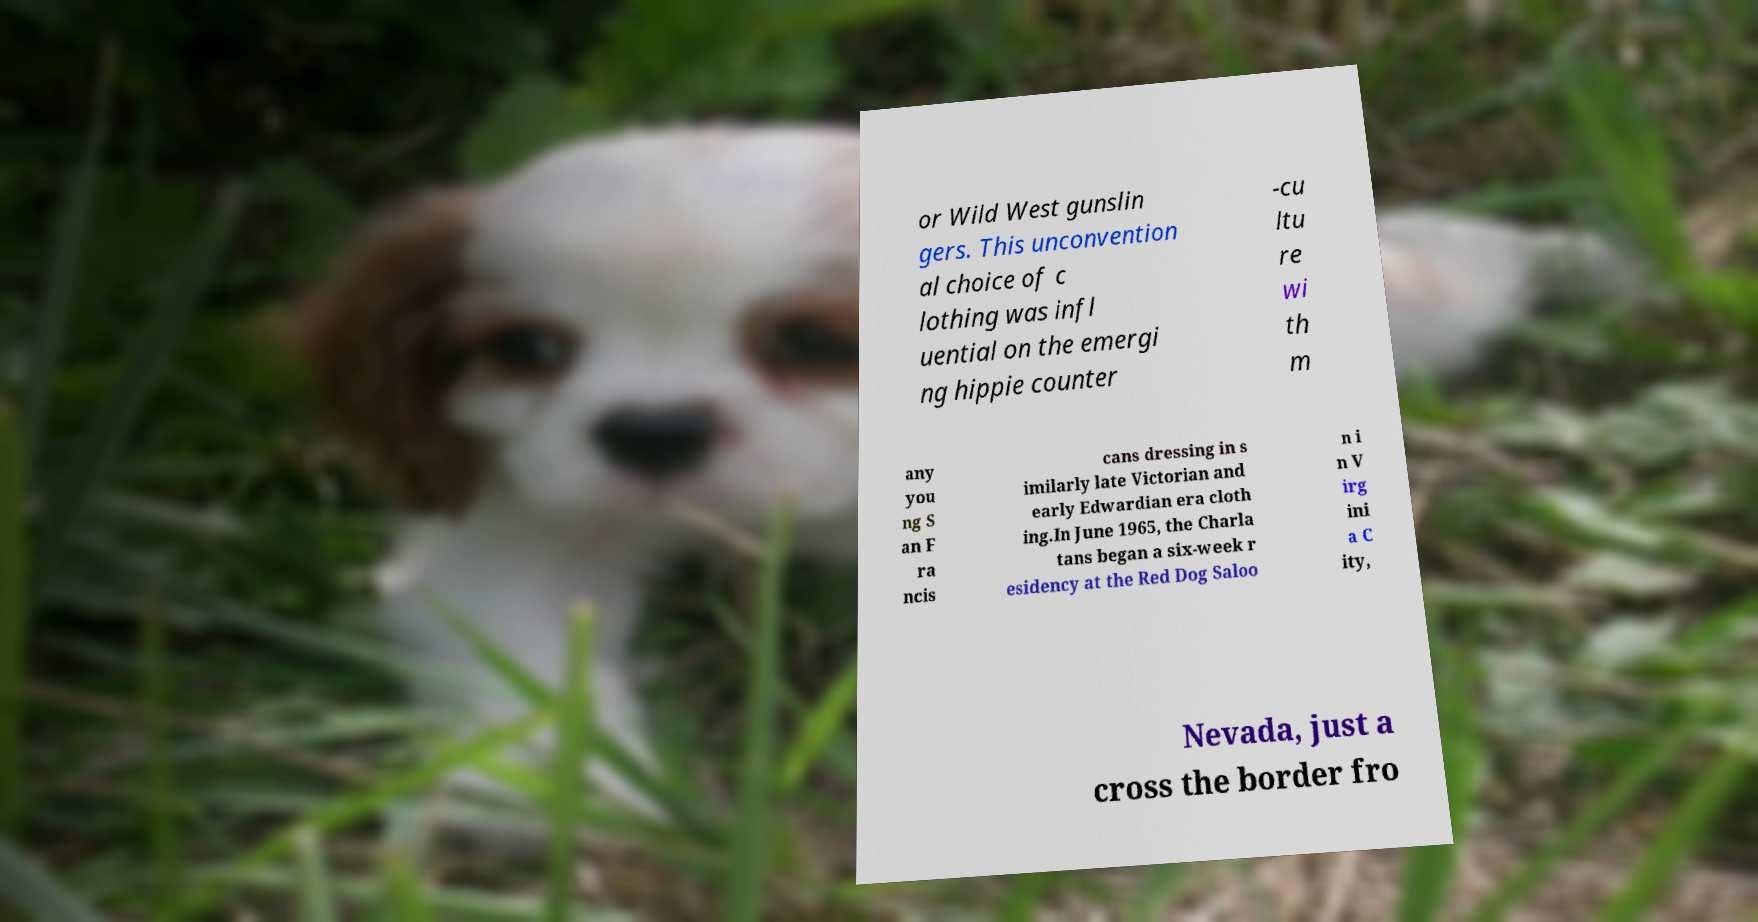Could you assist in decoding the text presented in this image and type it out clearly? or Wild West gunslin gers. This unconvention al choice of c lothing was infl uential on the emergi ng hippie counter -cu ltu re wi th m any you ng S an F ra ncis cans dressing in s imilarly late Victorian and early Edwardian era cloth ing.In June 1965, the Charla tans began a six-week r esidency at the Red Dog Saloo n i n V irg ini a C ity, Nevada, just a cross the border fro 